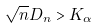<formula> <loc_0><loc_0><loc_500><loc_500>\sqrt { n } D _ { n } > K _ { \alpha }</formula> 